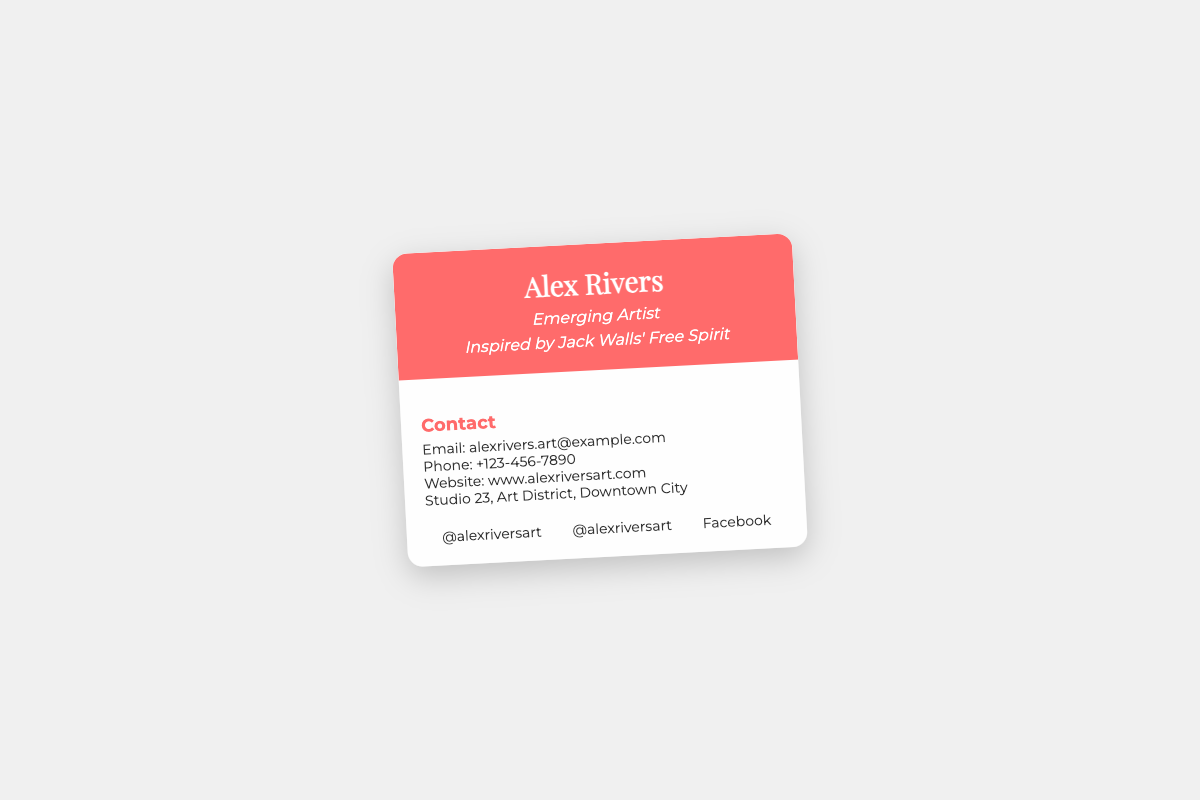what is the name of the artist? The artist's name is prominently displayed at the top of the card, which is Alex Rivers.
Answer: Alex Rivers what is the artist's email address? The card provides specific contact information, including the email, which is listed clearly.
Answer: alexrivers.art@example.com what is the phone number of the artist? The card features the artist's phone number under the contact information section.
Answer: +123-456-7890 where is the artist's studio located? The address of the artist's studio is given in the contact section of the card.
Answer: Studio 23, Art District, Downtown City what is the website of the artist? The website link is provided in the contact information on the card.
Answer: www.alexriversart.com what social media platform is mentioned first? The order of the social media links is essential, and the first mentioned is Instagram.
Answer: Instagram why is Jack Walls mentioned on the card? The mention of Jack Walls indicates an inspiration that influences the artist's work.
Answer: Inspiration how does the card react when hovered over? The card is designed to animate when interacted with, specifically rotating and scaling slightly.
Answer: Rotate and scale what is the aesthetic font used in the card header? The font used for the header is distinct and artistic, contributing to the overall aesthetic of the card.
Answer: Playfair Display 